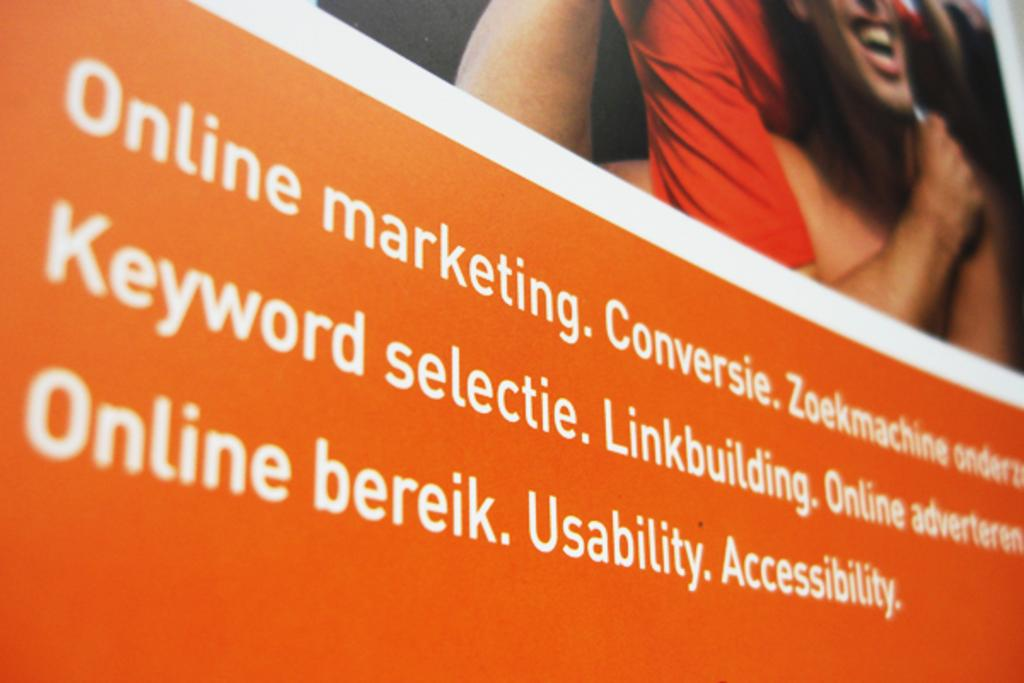What is present in the image that has both text and a picture on it? There is a banner in the image that has text and a picture on it. Can you describe the banner's content? The banner has text and a picture on it. Where is the person located in the image? The person is at the top of the image. What is present at the bottom of the image on the banner? There is text at the bottom of the image on the banner. What type of curtain is hanging from the person's hand in the image? There is no curtain present in the image; the person is not holding anything. 